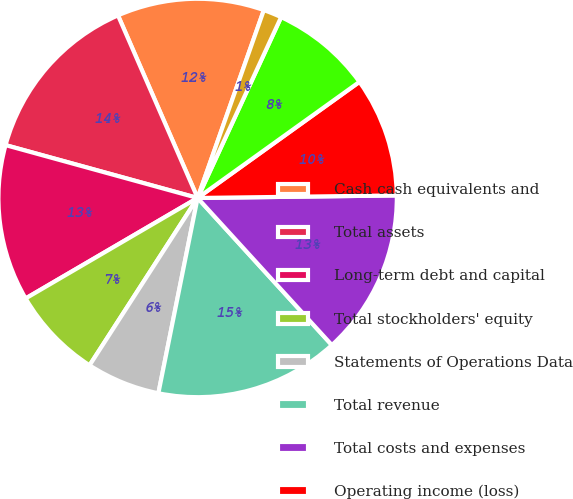<chart> <loc_0><loc_0><loc_500><loc_500><pie_chart><fcel>Cash cash equivalents and<fcel>Total assets<fcel>Long-term debt and capital<fcel>Total stockholders' equity<fcel>Statements of Operations Data<fcel>Total revenue<fcel>Total costs and expenses<fcel>Operating income (loss)<fcel>Net income (loss) attributable<fcel>Basic net income (loss) per<nl><fcel>11.94%<fcel>14.18%<fcel>12.69%<fcel>7.46%<fcel>5.97%<fcel>14.93%<fcel>13.43%<fcel>9.7%<fcel>8.21%<fcel>1.49%<nl></chart> 